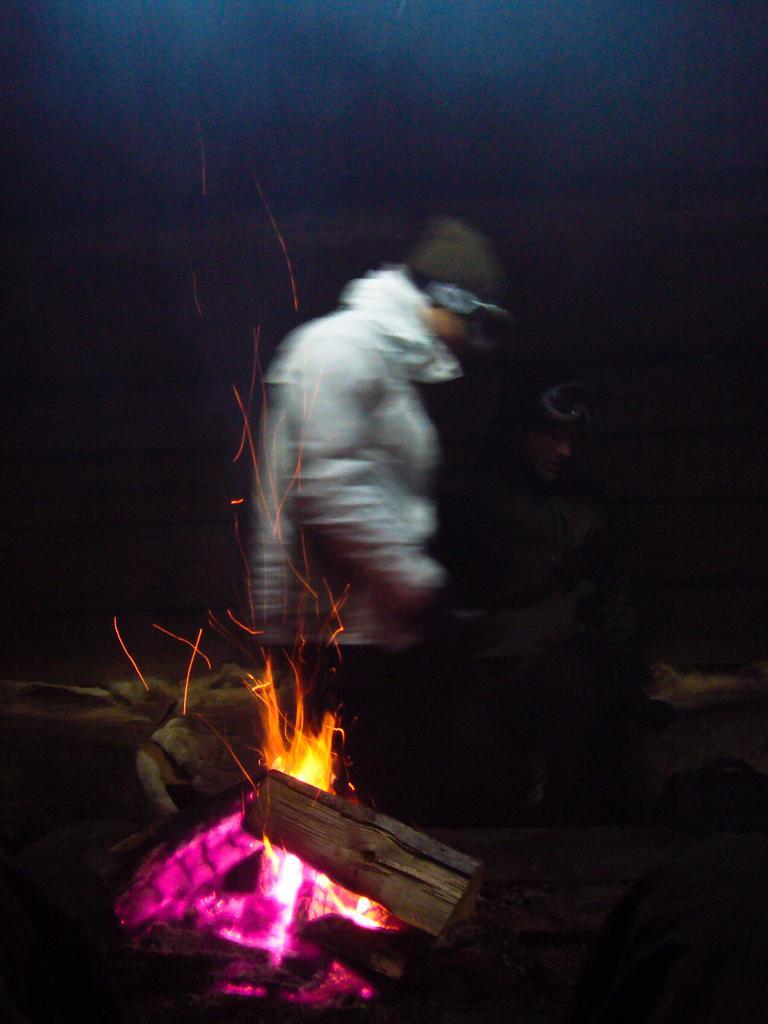In one or two sentences, can you explain what this image depicts? In the foreground of the picture there is flame and wood burning. In the center of the picture there are two persons wearing jackets. In the background it is dark. 